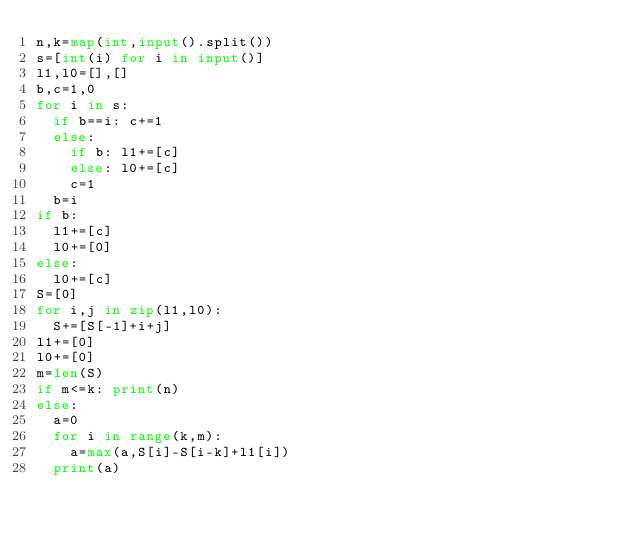<code> <loc_0><loc_0><loc_500><loc_500><_Python_>n,k=map(int,input().split())
s=[int(i) for i in input()]
l1,l0=[],[]
b,c=1,0
for i in s:
  if b==i: c+=1
  else:
    if b: l1+=[c]
    else: l0+=[c]
    c=1
  b=i
if b:
  l1+=[c]
  l0+=[0]
else:
  l0+=[c]
S=[0]
for i,j in zip(l1,l0):
  S+=[S[-1]+i+j]
l1+=[0]
l0+=[0]
m=len(S)
if m<=k: print(n)
else:
  a=0
  for i in range(k,m):
    a=max(a,S[i]-S[i-k]+l1[i])
  print(a)</code> 